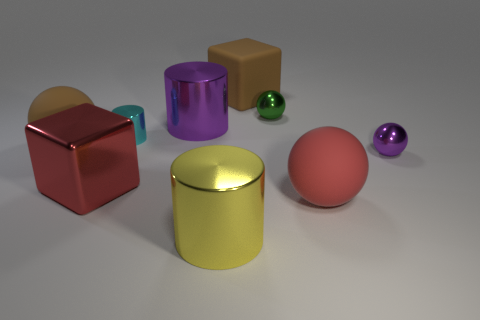Add 1 big cylinders. How many objects exist? 10 Subtract all blocks. How many objects are left? 7 Subtract 0 gray blocks. How many objects are left? 9 Subtract all small gray spheres. Subtract all metallic cylinders. How many objects are left? 6 Add 1 tiny cyan objects. How many tiny cyan objects are left? 2 Add 4 brown rubber things. How many brown rubber things exist? 6 